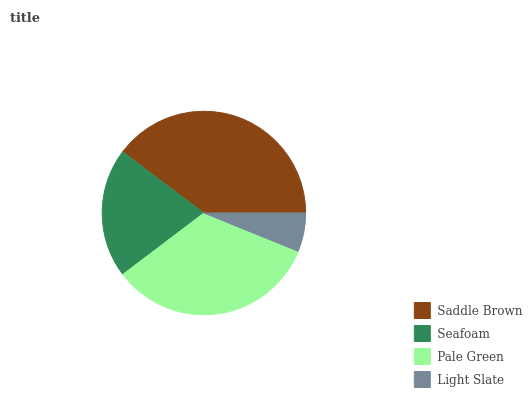Is Light Slate the minimum?
Answer yes or no. Yes. Is Saddle Brown the maximum?
Answer yes or no. Yes. Is Seafoam the minimum?
Answer yes or no. No. Is Seafoam the maximum?
Answer yes or no. No. Is Saddle Brown greater than Seafoam?
Answer yes or no. Yes. Is Seafoam less than Saddle Brown?
Answer yes or no. Yes. Is Seafoam greater than Saddle Brown?
Answer yes or no. No. Is Saddle Brown less than Seafoam?
Answer yes or no. No. Is Pale Green the high median?
Answer yes or no. Yes. Is Seafoam the low median?
Answer yes or no. Yes. Is Saddle Brown the high median?
Answer yes or no. No. Is Saddle Brown the low median?
Answer yes or no. No. 